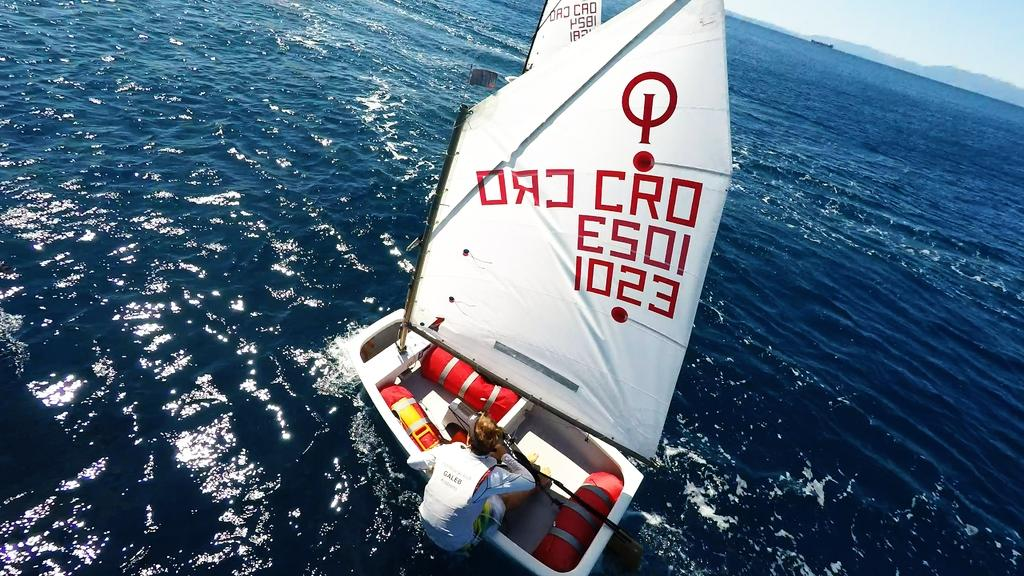What is the main subject of the image? There is a boat in the image. Who is in the boat? A man is sitting in the boat. What is the white cloth used for? The white cloth has text written in red color, which suggests it might be a banner or sign. What is visible at the bottom of the image? There is water visible at the bottom of the image. What type of flower can be seen growing on the man's leg in the image? There is no flower growing on the man's leg in the image. 